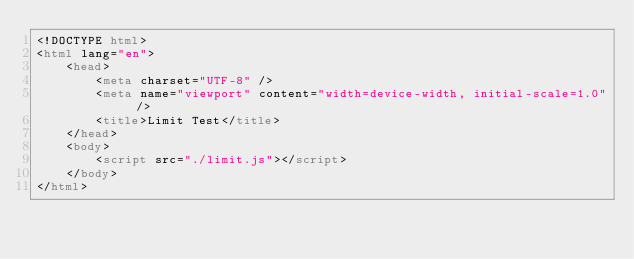<code> <loc_0><loc_0><loc_500><loc_500><_HTML_><!DOCTYPE html>
<html lang="en">
    <head>
        <meta charset="UTF-8" />
        <meta name="viewport" content="width=device-width, initial-scale=1.0" />
        <title>Limit Test</title>
    </head>
    <body>
        <script src="./limit.js"></script>
    </body>
</html>
</code> 